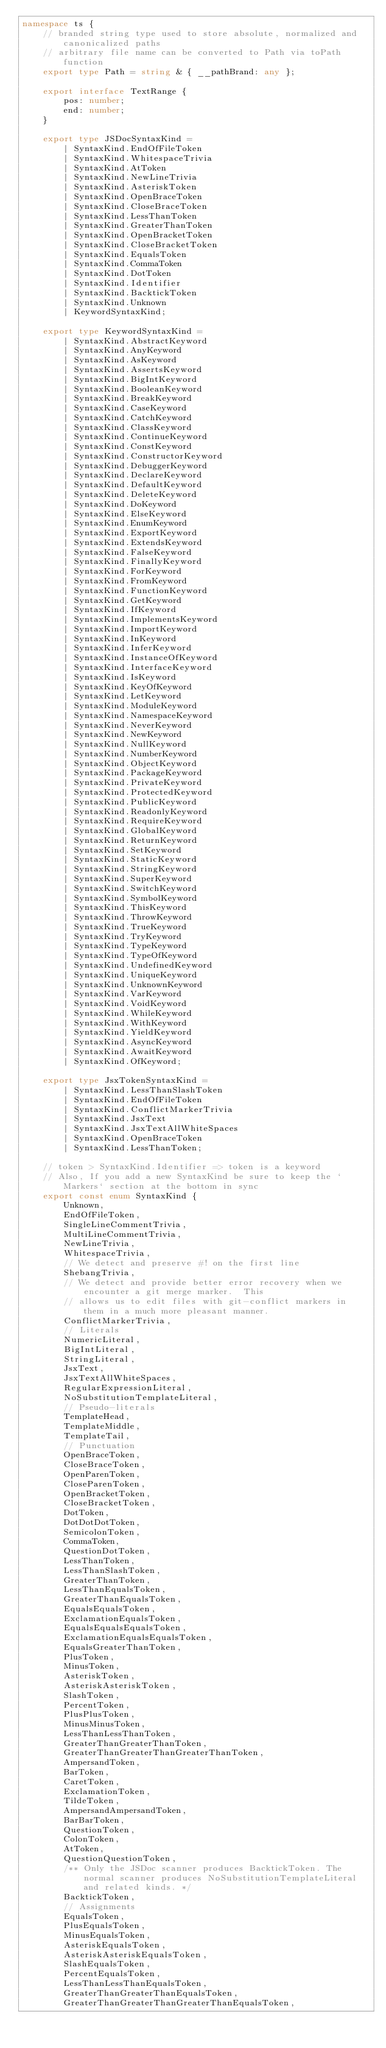<code> <loc_0><loc_0><loc_500><loc_500><_TypeScript_>namespace ts {
    // branded string type used to store absolute, normalized and canonicalized paths
    // arbitrary file name can be converted to Path via toPath function
    export type Path = string & { __pathBrand: any };

    export interface TextRange {
        pos: number;
        end: number;
    }

    export type JSDocSyntaxKind =
        | SyntaxKind.EndOfFileToken
        | SyntaxKind.WhitespaceTrivia
        | SyntaxKind.AtToken
        | SyntaxKind.NewLineTrivia
        | SyntaxKind.AsteriskToken
        | SyntaxKind.OpenBraceToken
        | SyntaxKind.CloseBraceToken
        | SyntaxKind.LessThanToken
        | SyntaxKind.GreaterThanToken
        | SyntaxKind.OpenBracketToken
        | SyntaxKind.CloseBracketToken
        | SyntaxKind.EqualsToken
        | SyntaxKind.CommaToken
        | SyntaxKind.DotToken
        | SyntaxKind.Identifier
        | SyntaxKind.BacktickToken
        | SyntaxKind.Unknown
        | KeywordSyntaxKind;

    export type KeywordSyntaxKind =
        | SyntaxKind.AbstractKeyword
        | SyntaxKind.AnyKeyword
        | SyntaxKind.AsKeyword
        | SyntaxKind.AssertsKeyword
        | SyntaxKind.BigIntKeyword
        | SyntaxKind.BooleanKeyword
        | SyntaxKind.BreakKeyword
        | SyntaxKind.CaseKeyword
        | SyntaxKind.CatchKeyword
        | SyntaxKind.ClassKeyword
        | SyntaxKind.ContinueKeyword
        | SyntaxKind.ConstKeyword
        | SyntaxKind.ConstructorKeyword
        | SyntaxKind.DebuggerKeyword
        | SyntaxKind.DeclareKeyword
        | SyntaxKind.DefaultKeyword
        | SyntaxKind.DeleteKeyword
        | SyntaxKind.DoKeyword
        | SyntaxKind.ElseKeyword
        | SyntaxKind.EnumKeyword
        | SyntaxKind.ExportKeyword
        | SyntaxKind.ExtendsKeyword
        | SyntaxKind.FalseKeyword
        | SyntaxKind.FinallyKeyword
        | SyntaxKind.ForKeyword
        | SyntaxKind.FromKeyword
        | SyntaxKind.FunctionKeyword
        | SyntaxKind.GetKeyword
        | SyntaxKind.IfKeyword
        | SyntaxKind.ImplementsKeyword
        | SyntaxKind.ImportKeyword
        | SyntaxKind.InKeyword
        | SyntaxKind.InferKeyword
        | SyntaxKind.InstanceOfKeyword
        | SyntaxKind.InterfaceKeyword
        | SyntaxKind.IsKeyword
        | SyntaxKind.KeyOfKeyword
        | SyntaxKind.LetKeyword
        | SyntaxKind.ModuleKeyword
        | SyntaxKind.NamespaceKeyword
        | SyntaxKind.NeverKeyword
        | SyntaxKind.NewKeyword
        | SyntaxKind.NullKeyword
        | SyntaxKind.NumberKeyword
        | SyntaxKind.ObjectKeyword
        | SyntaxKind.PackageKeyword
        | SyntaxKind.PrivateKeyword
        | SyntaxKind.ProtectedKeyword
        | SyntaxKind.PublicKeyword
        | SyntaxKind.ReadonlyKeyword
        | SyntaxKind.RequireKeyword
        | SyntaxKind.GlobalKeyword
        | SyntaxKind.ReturnKeyword
        | SyntaxKind.SetKeyword
        | SyntaxKind.StaticKeyword
        | SyntaxKind.StringKeyword
        | SyntaxKind.SuperKeyword
        | SyntaxKind.SwitchKeyword
        | SyntaxKind.SymbolKeyword
        | SyntaxKind.ThisKeyword
        | SyntaxKind.ThrowKeyword
        | SyntaxKind.TrueKeyword
        | SyntaxKind.TryKeyword
        | SyntaxKind.TypeKeyword
        | SyntaxKind.TypeOfKeyword
        | SyntaxKind.UndefinedKeyword
        | SyntaxKind.UniqueKeyword
        | SyntaxKind.UnknownKeyword
        | SyntaxKind.VarKeyword
        | SyntaxKind.VoidKeyword
        | SyntaxKind.WhileKeyword
        | SyntaxKind.WithKeyword
        | SyntaxKind.YieldKeyword
        | SyntaxKind.AsyncKeyword
        | SyntaxKind.AwaitKeyword
        | SyntaxKind.OfKeyword;

    export type JsxTokenSyntaxKind =
        | SyntaxKind.LessThanSlashToken
        | SyntaxKind.EndOfFileToken
        | SyntaxKind.ConflictMarkerTrivia
        | SyntaxKind.JsxText
        | SyntaxKind.JsxTextAllWhiteSpaces
        | SyntaxKind.OpenBraceToken
        | SyntaxKind.LessThanToken;

    // token > SyntaxKind.Identifier => token is a keyword
    // Also, If you add a new SyntaxKind be sure to keep the `Markers` section at the bottom in sync
    export const enum SyntaxKind {
        Unknown,
        EndOfFileToken,
        SingleLineCommentTrivia,
        MultiLineCommentTrivia,
        NewLineTrivia,
        WhitespaceTrivia,
        // We detect and preserve #! on the first line
        ShebangTrivia,
        // We detect and provide better error recovery when we encounter a git merge marker.  This
        // allows us to edit files with git-conflict markers in them in a much more pleasant manner.
        ConflictMarkerTrivia,
        // Literals
        NumericLiteral,
        BigIntLiteral,
        StringLiteral,
        JsxText,
        JsxTextAllWhiteSpaces,
        RegularExpressionLiteral,
        NoSubstitutionTemplateLiteral,
        // Pseudo-literals
        TemplateHead,
        TemplateMiddle,
        TemplateTail,
        // Punctuation
        OpenBraceToken,
        CloseBraceToken,
        OpenParenToken,
        CloseParenToken,
        OpenBracketToken,
        CloseBracketToken,
        DotToken,
        DotDotDotToken,
        SemicolonToken,
        CommaToken,
        QuestionDotToken,
        LessThanToken,
        LessThanSlashToken,
        GreaterThanToken,
        LessThanEqualsToken,
        GreaterThanEqualsToken,
        EqualsEqualsToken,
        ExclamationEqualsToken,
        EqualsEqualsEqualsToken,
        ExclamationEqualsEqualsToken,
        EqualsGreaterThanToken,
        PlusToken,
        MinusToken,
        AsteriskToken,
        AsteriskAsteriskToken,
        SlashToken,
        PercentToken,
        PlusPlusToken,
        MinusMinusToken,
        LessThanLessThanToken,
        GreaterThanGreaterThanToken,
        GreaterThanGreaterThanGreaterThanToken,
        AmpersandToken,
        BarToken,
        CaretToken,
        ExclamationToken,
        TildeToken,
        AmpersandAmpersandToken,
        BarBarToken,
        QuestionToken,
        ColonToken,
        AtToken,
        QuestionQuestionToken,
        /** Only the JSDoc scanner produces BacktickToken. The normal scanner produces NoSubstitutionTemplateLiteral and related kinds. */
        BacktickToken,
        // Assignments
        EqualsToken,
        PlusEqualsToken,
        MinusEqualsToken,
        AsteriskEqualsToken,
        AsteriskAsteriskEqualsToken,
        SlashEqualsToken,
        PercentEqualsToken,
        LessThanLessThanEqualsToken,
        GreaterThanGreaterThanEqualsToken,
        GreaterThanGreaterThanGreaterThanEqualsToken,</code> 